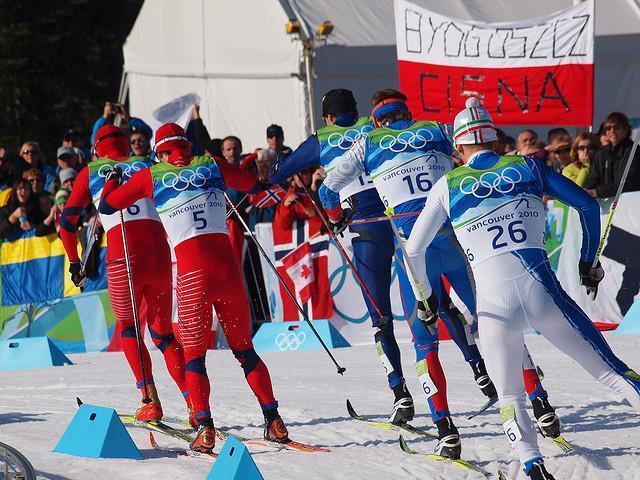How many red skiers do you see?
Give a very brief answer. 2. How many people are there?
Give a very brief answer. 7. How many sheep are there?
Give a very brief answer. 0. 